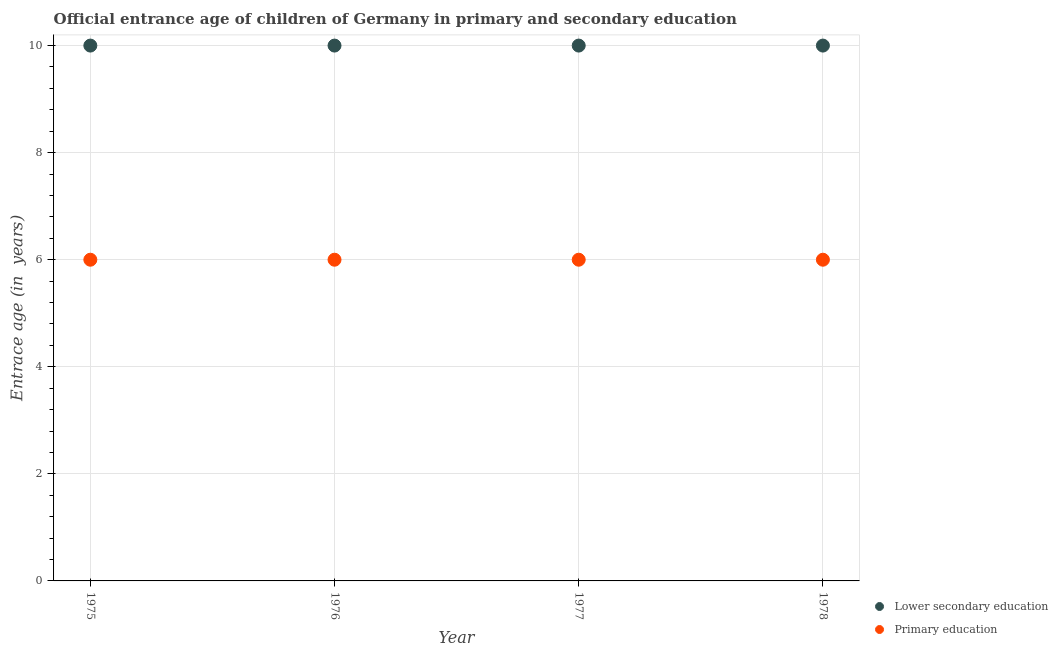How many different coloured dotlines are there?
Give a very brief answer. 2. Is the number of dotlines equal to the number of legend labels?
Offer a terse response. Yes. What is the entrance age of children in lower secondary education in 1978?
Your answer should be compact. 10. Across all years, what is the maximum entrance age of children in lower secondary education?
Make the answer very short. 10. Across all years, what is the minimum entrance age of children in lower secondary education?
Provide a short and direct response. 10. In which year was the entrance age of chiildren in primary education maximum?
Provide a short and direct response. 1975. In which year was the entrance age of chiildren in primary education minimum?
Offer a very short reply. 1975. What is the total entrance age of children in lower secondary education in the graph?
Ensure brevity in your answer.  40. What is the difference between the entrance age of chiildren in primary education in 1975 and the entrance age of children in lower secondary education in 1977?
Offer a terse response. -4. In the year 1978, what is the difference between the entrance age of chiildren in primary education and entrance age of children in lower secondary education?
Keep it short and to the point. -4. In how many years, is the entrance age of chiildren in primary education greater than 4.8 years?
Your response must be concise. 4. What is the ratio of the entrance age of chiildren in primary education in 1975 to that in 1976?
Your response must be concise. 1. Is the entrance age of children in lower secondary education in 1977 less than that in 1978?
Provide a succinct answer. No. What is the difference between the highest and the second highest entrance age of children in lower secondary education?
Offer a very short reply. 0. What is the difference between the highest and the lowest entrance age of children in lower secondary education?
Provide a short and direct response. 0. In how many years, is the entrance age of chiildren in primary education greater than the average entrance age of chiildren in primary education taken over all years?
Your response must be concise. 0. Does the entrance age of chiildren in primary education monotonically increase over the years?
Provide a short and direct response. No. Is the entrance age of children in lower secondary education strictly greater than the entrance age of chiildren in primary education over the years?
Your answer should be compact. Yes. How many dotlines are there?
Your answer should be very brief. 2. What is the difference between two consecutive major ticks on the Y-axis?
Offer a very short reply. 2. How many legend labels are there?
Your answer should be compact. 2. How are the legend labels stacked?
Provide a succinct answer. Vertical. What is the title of the graph?
Give a very brief answer. Official entrance age of children of Germany in primary and secondary education. Does "current US$" appear as one of the legend labels in the graph?
Offer a very short reply. No. What is the label or title of the X-axis?
Offer a terse response. Year. What is the label or title of the Y-axis?
Your answer should be compact. Entrace age (in  years). What is the Entrace age (in  years) in Primary education in 1976?
Your response must be concise. 6. What is the Entrace age (in  years) of Lower secondary education in 1978?
Make the answer very short. 10. What is the Entrace age (in  years) in Primary education in 1978?
Ensure brevity in your answer.  6. Across all years, what is the minimum Entrace age (in  years) of Lower secondary education?
Ensure brevity in your answer.  10. Across all years, what is the minimum Entrace age (in  years) in Primary education?
Ensure brevity in your answer.  6. What is the total Entrace age (in  years) of Lower secondary education in the graph?
Provide a short and direct response. 40. What is the difference between the Entrace age (in  years) of Primary education in 1975 and that in 1976?
Keep it short and to the point. 0. What is the difference between the Entrace age (in  years) of Primary education in 1975 and that in 1977?
Ensure brevity in your answer.  0. What is the difference between the Entrace age (in  years) of Lower secondary education in 1975 and that in 1978?
Provide a succinct answer. 0. What is the difference between the Entrace age (in  years) of Primary education in 1975 and that in 1978?
Your answer should be compact. 0. What is the difference between the Entrace age (in  years) in Lower secondary education in 1976 and that in 1977?
Offer a terse response. 0. What is the difference between the Entrace age (in  years) in Primary education in 1976 and that in 1977?
Your answer should be very brief. 0. What is the difference between the Entrace age (in  years) in Primary education in 1976 and that in 1978?
Ensure brevity in your answer.  0. What is the difference between the Entrace age (in  years) of Lower secondary education in 1977 and that in 1978?
Your answer should be very brief. 0. What is the difference between the Entrace age (in  years) of Primary education in 1977 and that in 1978?
Keep it short and to the point. 0. What is the difference between the Entrace age (in  years) of Lower secondary education in 1975 and the Entrace age (in  years) of Primary education in 1976?
Ensure brevity in your answer.  4. What is the difference between the Entrace age (in  years) in Lower secondary education in 1976 and the Entrace age (in  years) in Primary education in 1978?
Your response must be concise. 4. What is the average Entrace age (in  years) in Lower secondary education per year?
Provide a short and direct response. 10. In the year 1975, what is the difference between the Entrace age (in  years) of Lower secondary education and Entrace age (in  years) of Primary education?
Your answer should be very brief. 4. In the year 1976, what is the difference between the Entrace age (in  years) in Lower secondary education and Entrace age (in  years) in Primary education?
Your answer should be very brief. 4. What is the ratio of the Entrace age (in  years) in Primary education in 1975 to that in 1976?
Offer a very short reply. 1. What is the ratio of the Entrace age (in  years) of Lower secondary education in 1975 to that in 1977?
Give a very brief answer. 1. What is the ratio of the Entrace age (in  years) in Primary education in 1975 to that in 1977?
Offer a very short reply. 1. What is the ratio of the Entrace age (in  years) of Lower secondary education in 1975 to that in 1978?
Keep it short and to the point. 1. What is the ratio of the Entrace age (in  years) in Primary education in 1975 to that in 1978?
Your response must be concise. 1. What is the ratio of the Entrace age (in  years) of Lower secondary education in 1976 to that in 1977?
Provide a succinct answer. 1. What is the ratio of the Entrace age (in  years) of Primary education in 1976 to that in 1977?
Your answer should be very brief. 1. What is the ratio of the Entrace age (in  years) in Lower secondary education in 1976 to that in 1978?
Your answer should be compact. 1. What is the ratio of the Entrace age (in  years) in Primary education in 1977 to that in 1978?
Provide a succinct answer. 1. What is the difference between the highest and the second highest Entrace age (in  years) in Lower secondary education?
Provide a short and direct response. 0. 